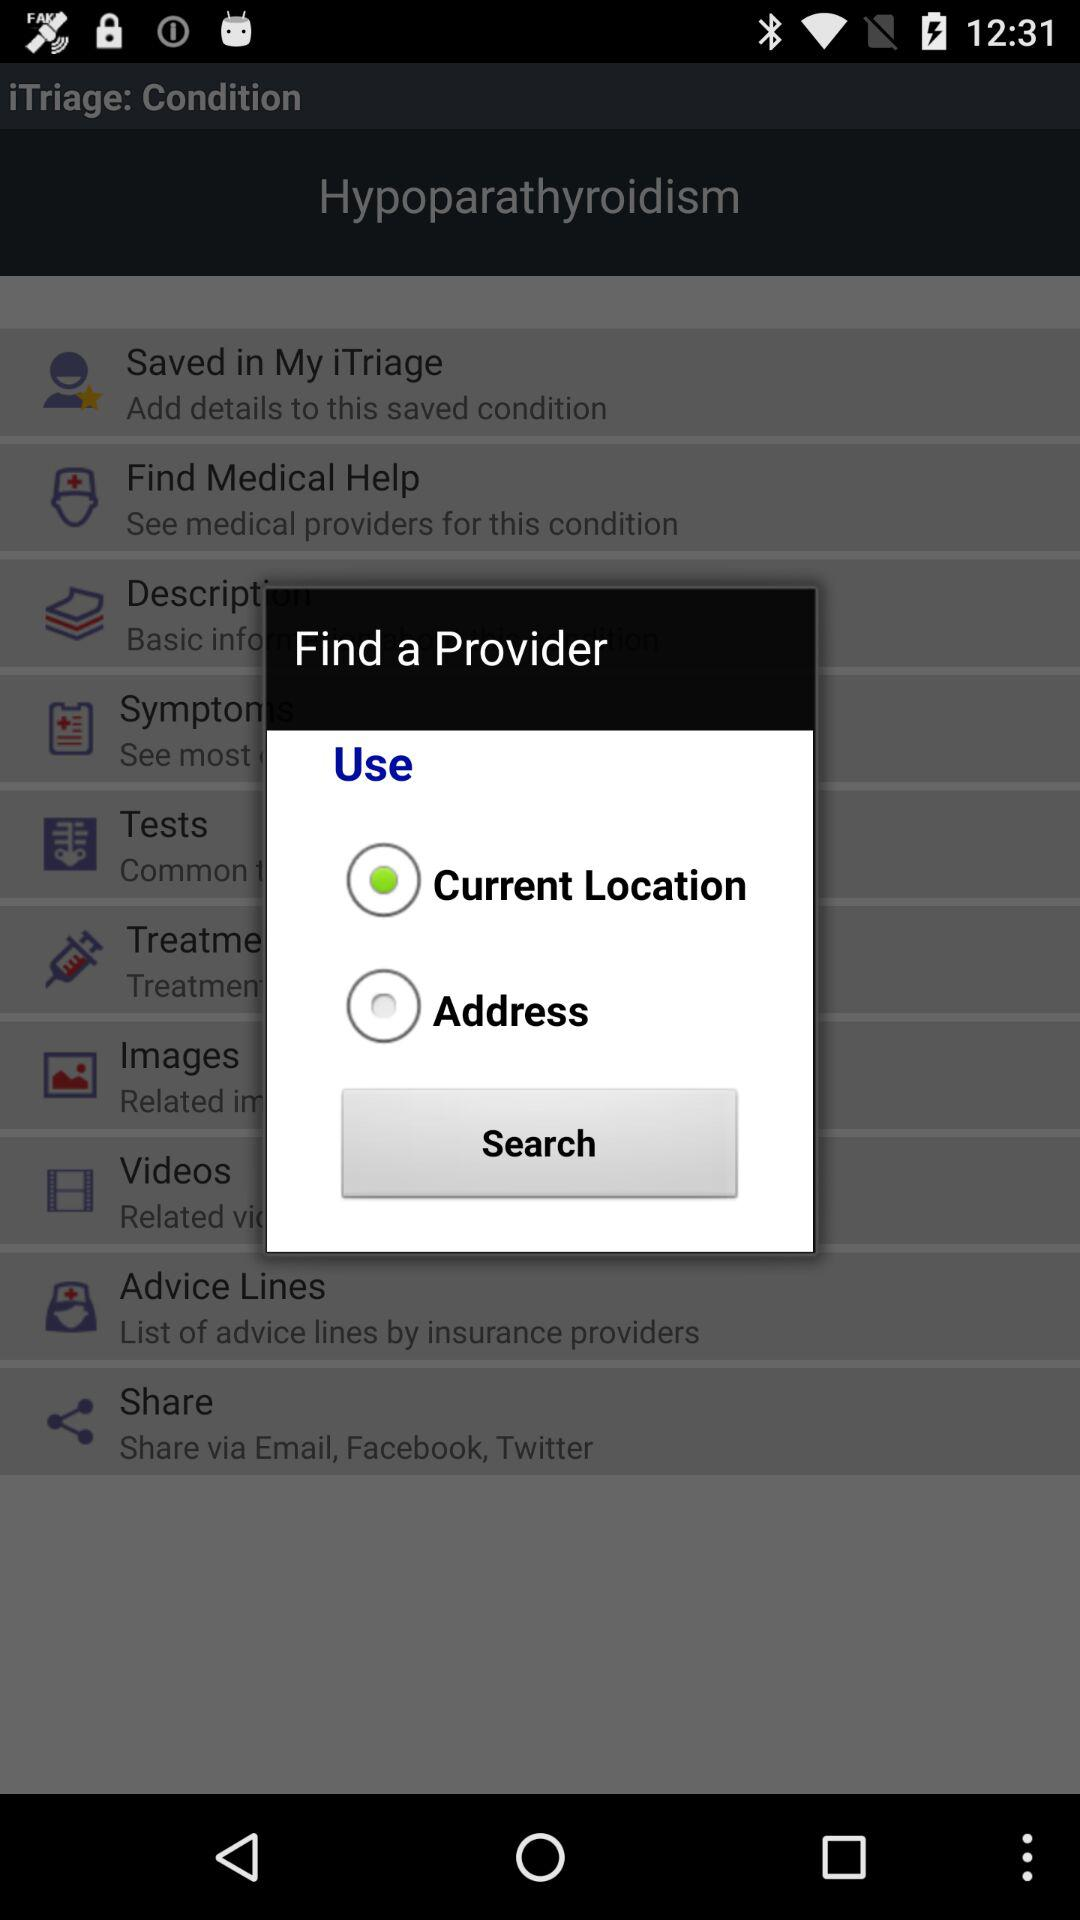What is the name of the medical condition? The name of the medical condition is hypoparathyroidism. 